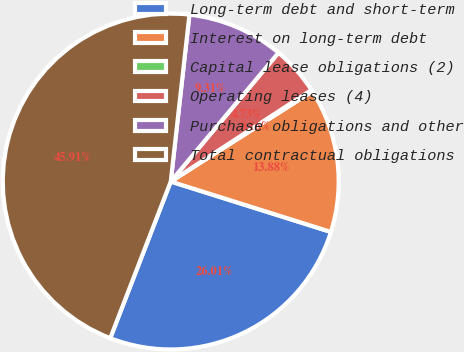<chart> <loc_0><loc_0><loc_500><loc_500><pie_chart><fcel>Long-term debt and short-term<fcel>Interest on long-term debt<fcel>Capital lease obligations (2)<fcel>Operating leases (4)<fcel>Purchase obligations and other<fcel>Total contractual obligations<nl><fcel>26.01%<fcel>13.88%<fcel>0.16%<fcel>4.73%<fcel>9.31%<fcel>45.91%<nl></chart> 